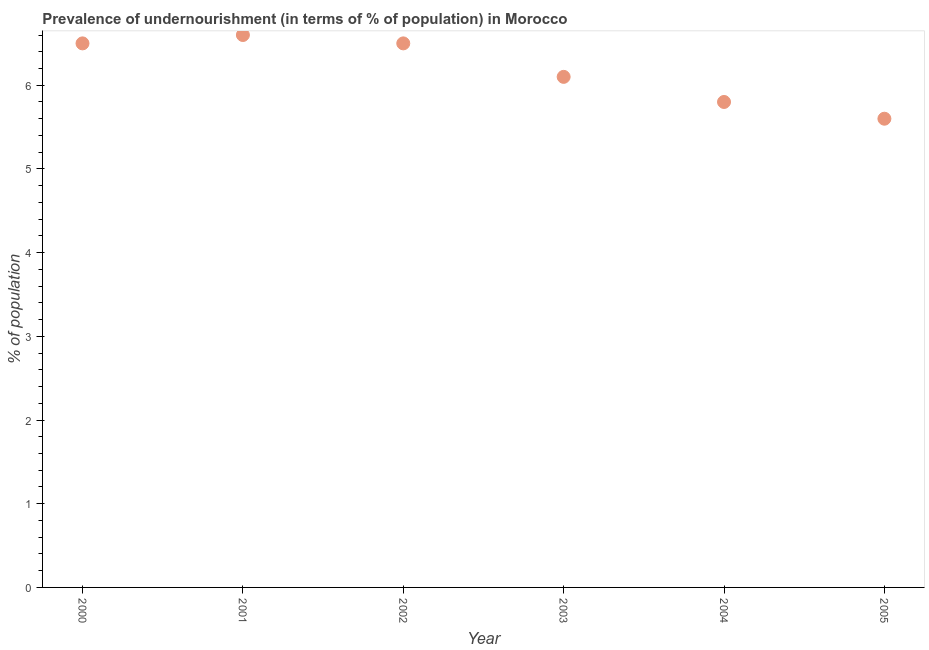What is the percentage of undernourished population in 2003?
Offer a terse response. 6.1. Across all years, what is the minimum percentage of undernourished population?
Make the answer very short. 5.6. In which year was the percentage of undernourished population minimum?
Your response must be concise. 2005. What is the sum of the percentage of undernourished population?
Make the answer very short. 37.1. What is the average percentage of undernourished population per year?
Offer a terse response. 6.18. What is the median percentage of undernourished population?
Offer a very short reply. 6.3. In how many years, is the percentage of undernourished population greater than 2.4 %?
Your response must be concise. 6. What is the ratio of the percentage of undernourished population in 2000 to that in 2005?
Provide a succinct answer. 1.16. Is the difference between the percentage of undernourished population in 2003 and 2005 greater than the difference between any two years?
Provide a succinct answer. No. What is the difference between the highest and the second highest percentage of undernourished population?
Give a very brief answer. 0.1. Is the sum of the percentage of undernourished population in 2001 and 2004 greater than the maximum percentage of undernourished population across all years?
Offer a very short reply. Yes. Does the percentage of undernourished population monotonically increase over the years?
Your answer should be very brief. No. What is the title of the graph?
Keep it short and to the point. Prevalence of undernourishment (in terms of % of population) in Morocco. What is the label or title of the Y-axis?
Your response must be concise. % of population. What is the % of population in 2000?
Your response must be concise. 6.5. What is the % of population in 2001?
Give a very brief answer. 6.6. What is the % of population in 2003?
Make the answer very short. 6.1. What is the % of population in 2005?
Provide a succinct answer. 5.6. What is the difference between the % of population in 2000 and 2001?
Keep it short and to the point. -0.1. What is the difference between the % of population in 2000 and 2002?
Your response must be concise. 0. What is the difference between the % of population in 2000 and 2004?
Make the answer very short. 0.7. What is the difference between the % of population in 2001 and 2002?
Offer a terse response. 0.1. What is the difference between the % of population in 2001 and 2004?
Make the answer very short. 0.8. What is the difference between the % of population in 2002 and 2003?
Keep it short and to the point. 0.4. What is the difference between the % of population in 2002 and 2004?
Keep it short and to the point. 0.7. What is the difference between the % of population in 2002 and 2005?
Your answer should be compact. 0.9. What is the difference between the % of population in 2003 and 2004?
Provide a succinct answer. 0.3. What is the ratio of the % of population in 2000 to that in 2003?
Ensure brevity in your answer.  1.07. What is the ratio of the % of population in 2000 to that in 2004?
Provide a short and direct response. 1.12. What is the ratio of the % of population in 2000 to that in 2005?
Offer a terse response. 1.16. What is the ratio of the % of population in 2001 to that in 2002?
Provide a succinct answer. 1.01. What is the ratio of the % of population in 2001 to that in 2003?
Keep it short and to the point. 1.08. What is the ratio of the % of population in 2001 to that in 2004?
Keep it short and to the point. 1.14. What is the ratio of the % of population in 2001 to that in 2005?
Offer a very short reply. 1.18. What is the ratio of the % of population in 2002 to that in 2003?
Keep it short and to the point. 1.07. What is the ratio of the % of population in 2002 to that in 2004?
Your answer should be compact. 1.12. What is the ratio of the % of population in 2002 to that in 2005?
Give a very brief answer. 1.16. What is the ratio of the % of population in 2003 to that in 2004?
Your response must be concise. 1.05. What is the ratio of the % of population in 2003 to that in 2005?
Your response must be concise. 1.09. What is the ratio of the % of population in 2004 to that in 2005?
Offer a terse response. 1.04. 